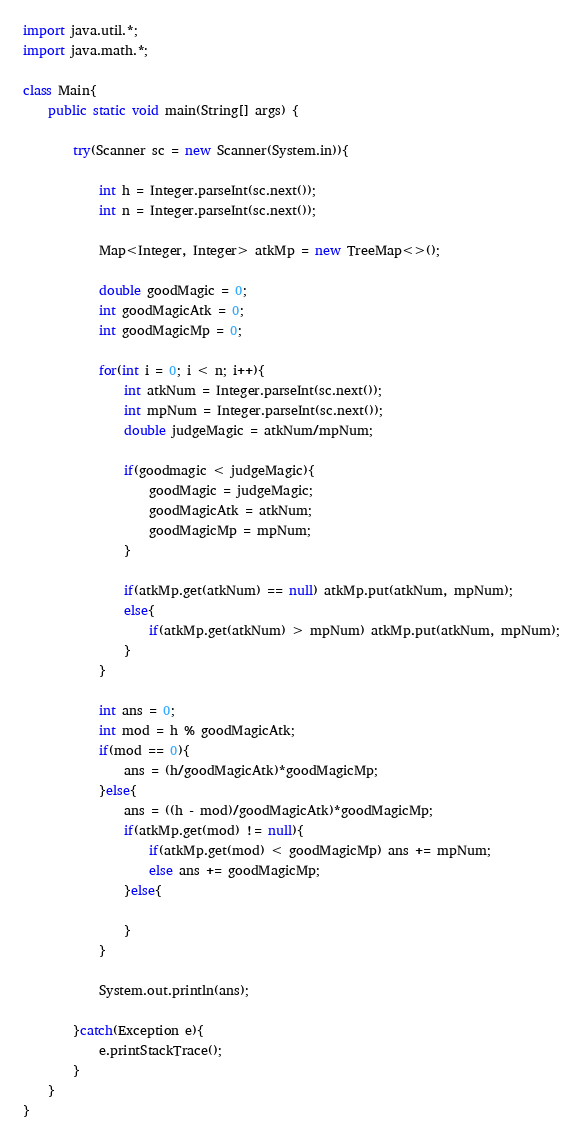<code> <loc_0><loc_0><loc_500><loc_500><_Java_>import java.util.*;
import java.math.*;
     
class Main{
    public static void main(String[] args) {
        
        try(Scanner sc = new Scanner(System.in)){
 
            int h = Integer.parseInt(sc.next());
            int n = Integer.parseInt(sc.next());

            Map<Integer, Integer> atkMp = new TreeMap<>();

            double goodMagic = 0;
            int goodMagicAtk = 0;
            int goodMagicMp = 0;

            for(int i = 0; i < n; i++){
                int atkNum = Integer.parseInt(sc.next());
                int mpNum = Integer.parseInt(sc.next());
                double judgeMagic = atkNum/mpNum;

                if(goodmagic < judgeMagic){
                    goodMagic = judgeMagic;
                    goodMagicAtk = atkNum;
                    goodMagicMp = mpNum;
                }

                if(atkMp.get(atkNum) == null) atkMp.put(atkNum, mpNum);
                else{
                    if(atkMp.get(atkNum) > mpNum) atkMp.put(atkNum, mpNum);
                }
            }

            int ans = 0;
            int mod = h % goodMagicAtk;
            if(mod == 0){
                ans = (h/goodMagicAtk)*goodMagicMp;
            }else{
                ans = ((h - mod)/goodMagicAtk)*goodMagicMp;
                if(atkMp.get(mod) != null){
                    if(atkMp.get(mod) < goodMagicMp) ans += mpNum;
                    else ans += goodMagicMp;
                }else{

                }
            }

            System.out.println(ans);
 
        }catch(Exception e){
            e.printStackTrace();
        }        
    }
}</code> 